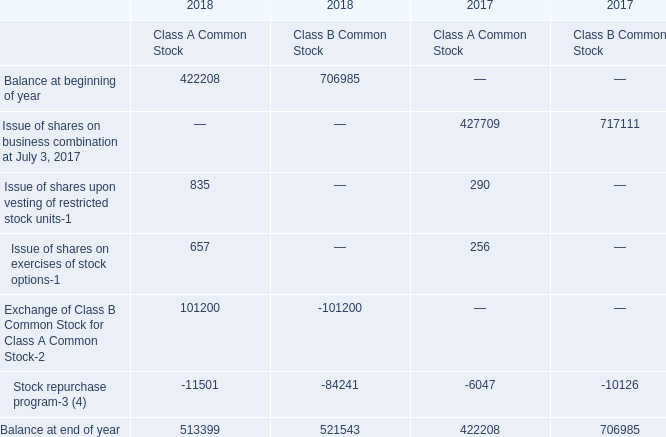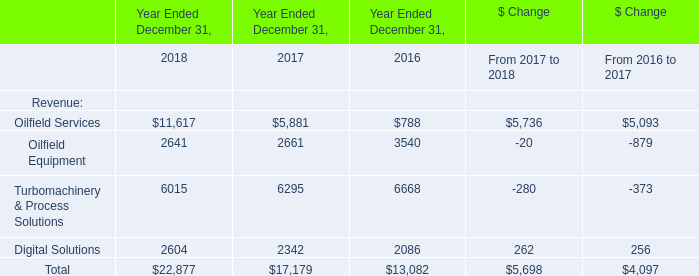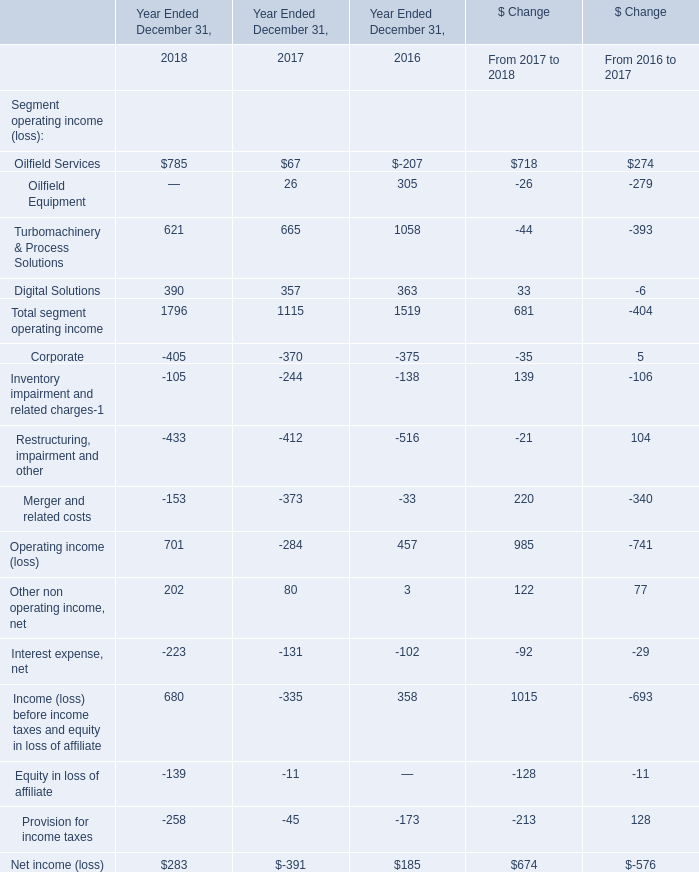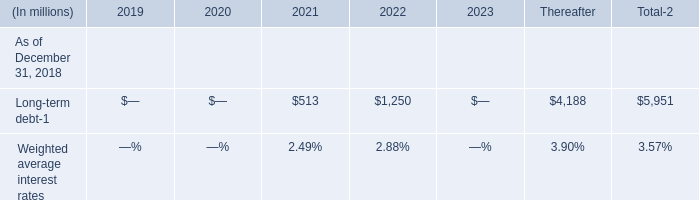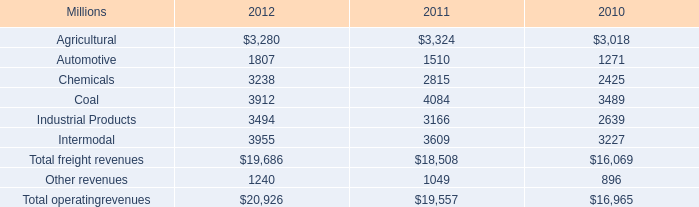What's the total amount of Oilfield Services,Oilfield Equipment ,urbomachinery & Process Solutions and Digital Solutions in 2018? (in million) 
Computations: (((11617 + 2641) + 6015) + 2604)
Answer: 22877.0. 